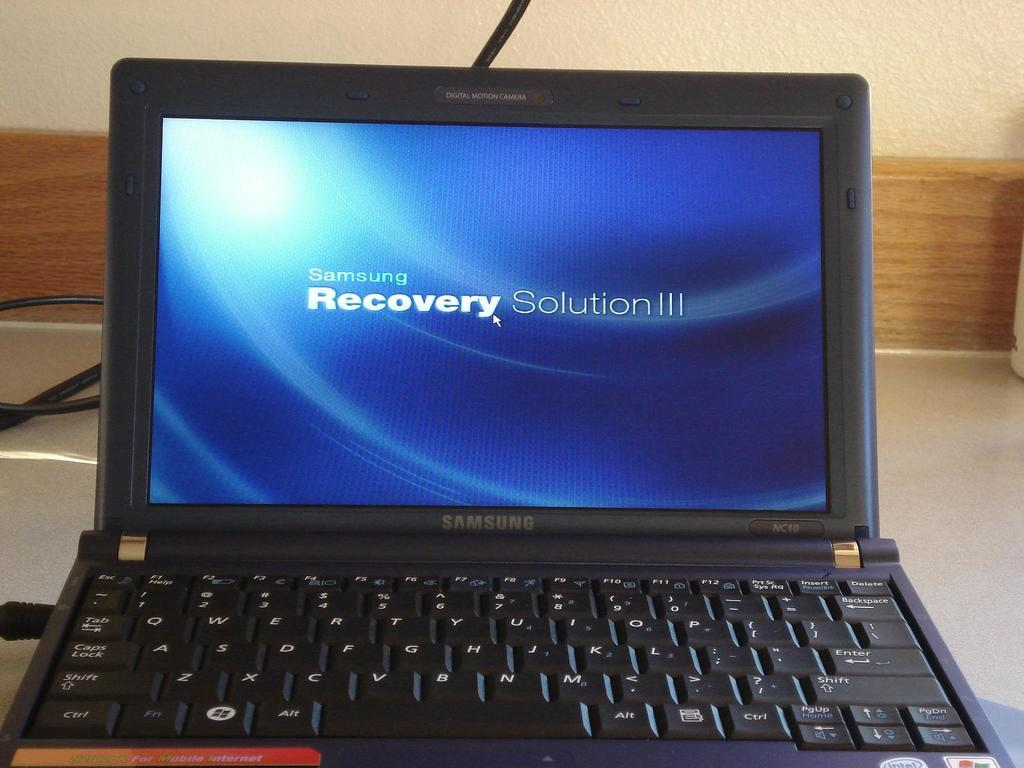<image>
Offer a succinct explanation of the picture presented. samsung laptop with blue recovery solution iii on the screen 